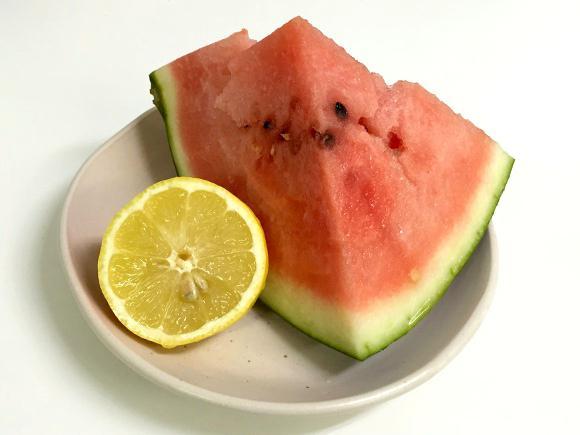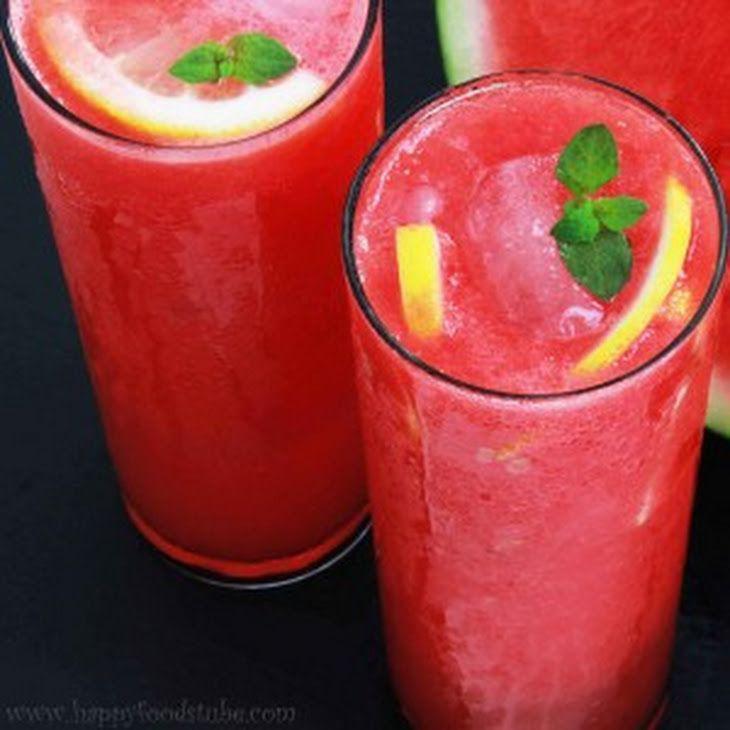The first image is the image on the left, the second image is the image on the right. Assess this claim about the two images: "One image shows drink ingredients only, including watermelon and lemon.". Correct or not? Answer yes or no. Yes. 